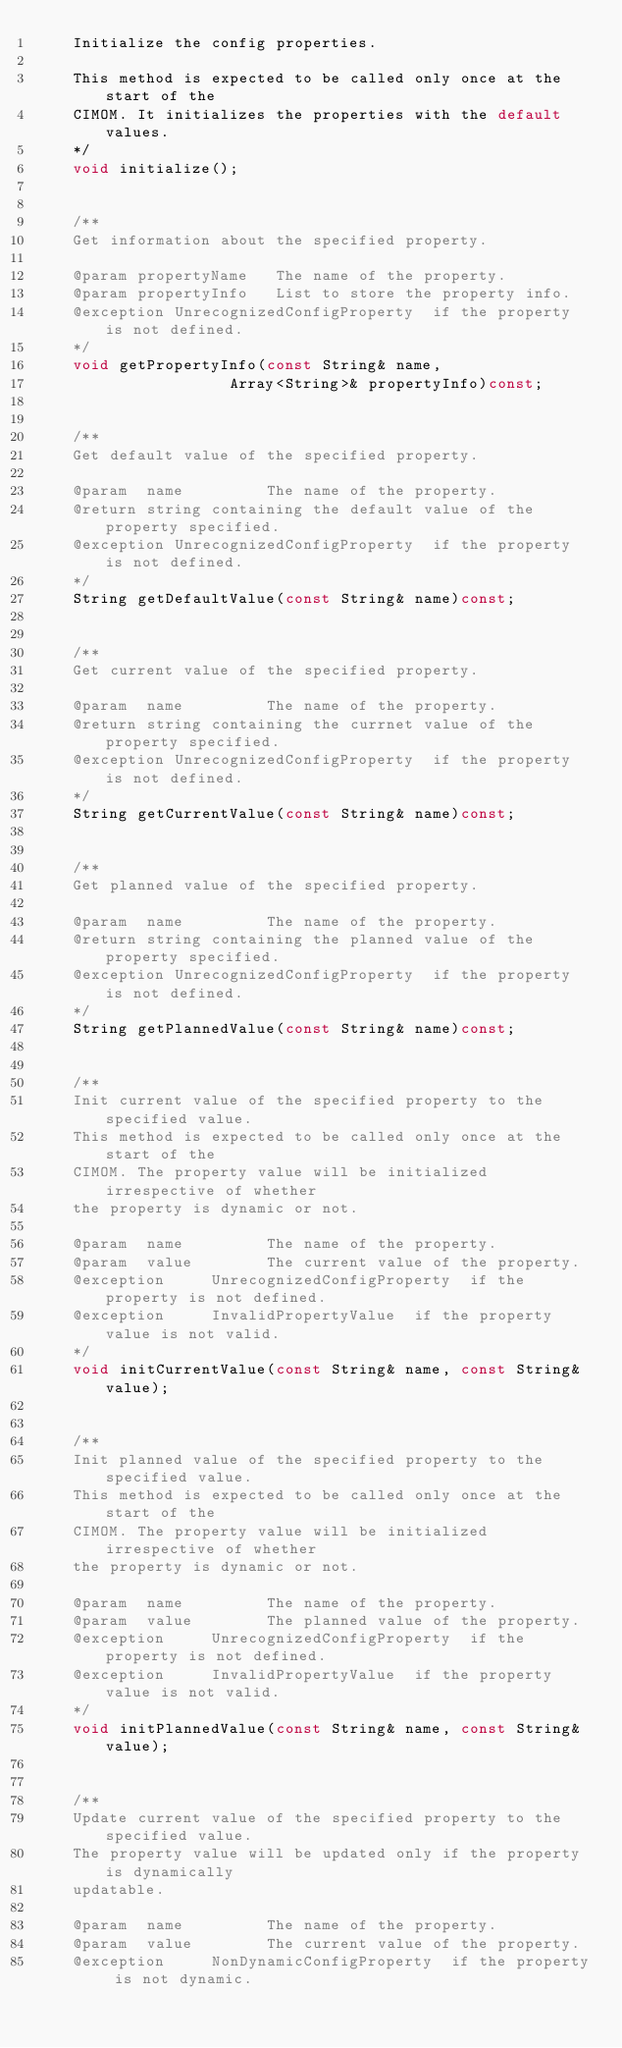Convert code to text. <code><loc_0><loc_0><loc_500><loc_500><_C_>    Initialize the config properties.

    This method is expected to be called only once at the start of the
    CIMOM. It initializes the properties with the default values.
    */
    void initialize();


    /**
    Get information about the specified property.

    @param propertyName   The name of the property.
    @param propertyInfo   List to store the property info.
    @exception UnrecognizedConfigProperty  if the property is not defined.
    */
    void getPropertyInfo(const String& name, 
                     Array<String>& propertyInfo)const;


    /**
    Get default value of the specified property.

    @param  name         The name of the property.
    @return string containing the default value of the property specified.
    @exception UnrecognizedConfigProperty  if the property is not defined.
    */
    String getDefaultValue(const String& name)const;


    /**
    Get current value of the specified property.

    @param  name         The name of the property.
    @return string containing the currnet value of the property specified.
    @exception UnrecognizedConfigProperty  if the property is not defined.
    */
    String getCurrentValue(const String& name)const;


    /**
    Get planned value of the specified property.

    @param  name         The name of the property.
    @return string containing the planned value of the property specified.
    @exception UnrecognizedConfigProperty  if the property is not defined.
    */
    String getPlannedValue(const String& name)const;


    /**
    Init current value of the specified property to the specified value.
    This method is expected to be called only once at the start of the
    CIMOM. The property value will be initialized irrespective of whether
    the property is dynamic or not.

    @param  name         The name of the property.
    @param  value        The current value of the property.
    @exception     UnrecognizedConfigProperty  if the property is not defined.
    @exception     InvalidPropertyValue  if the property value is not valid.
    */
    void initCurrentValue(const String& name, const String& value);


    /**
    Init planned value of the specified property to the specified value.
    This method is expected to be called only once at the start of the
    CIMOM. The property value will be initialized irrespective of whether
    the property is dynamic or not.

    @param  name         The name of the property.
    @param  value        The planned value of the property.
    @exception     UnrecognizedConfigProperty  if the property is not defined.
    @exception     InvalidPropertyValue  if the property value is not valid.
    */
    void initPlannedValue(const String& name, const String& value);


    /**
    Update current value of the specified property to the specified value.
    The property value will be updated only if the property is dynamically
    updatable.

    @param  name         The name of the property.
    @param  value        The current value of the property.
    @exception     NonDynamicConfigProperty  if the property is not dynamic.</code> 